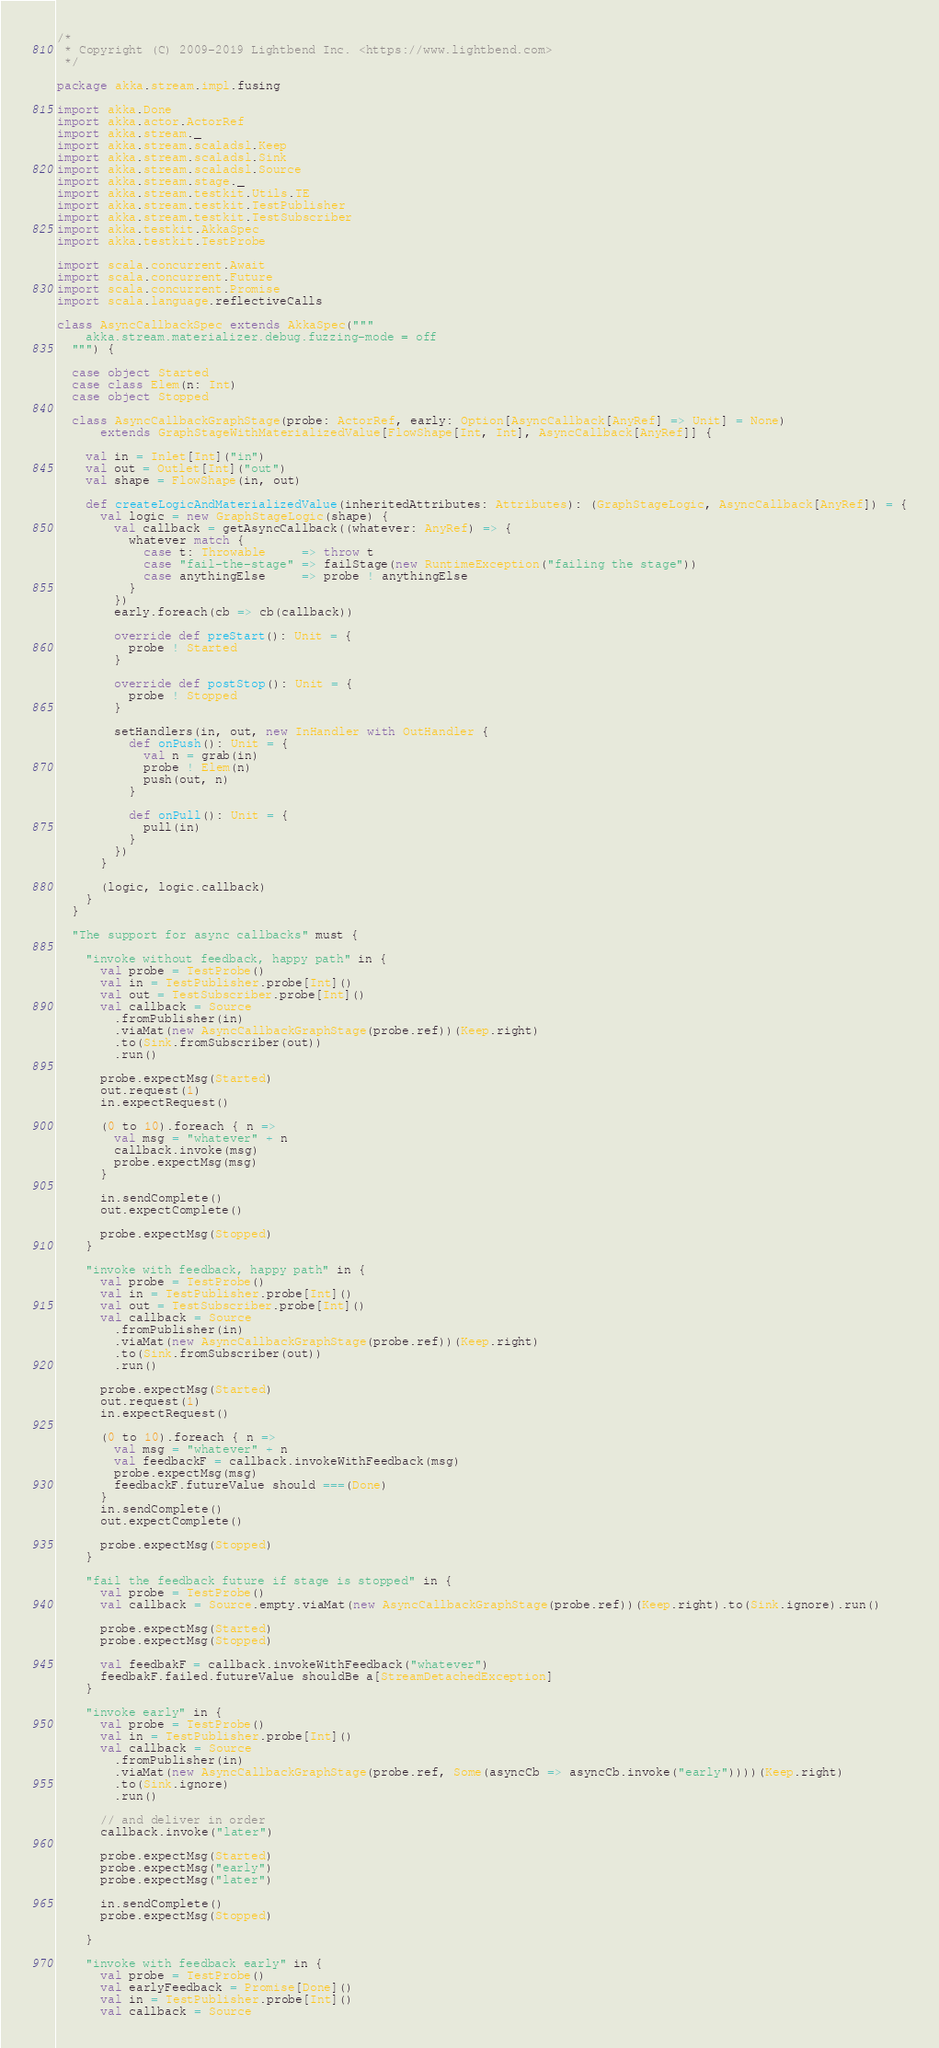Convert code to text. <code><loc_0><loc_0><loc_500><loc_500><_Scala_>/*
 * Copyright (C) 2009-2019 Lightbend Inc. <https://www.lightbend.com>
 */

package akka.stream.impl.fusing

import akka.Done
import akka.actor.ActorRef
import akka.stream._
import akka.stream.scaladsl.Keep
import akka.stream.scaladsl.Sink
import akka.stream.scaladsl.Source
import akka.stream.stage._
import akka.stream.testkit.Utils.TE
import akka.stream.testkit.TestPublisher
import akka.stream.testkit.TestSubscriber
import akka.testkit.AkkaSpec
import akka.testkit.TestProbe

import scala.concurrent.Await
import scala.concurrent.Future
import scala.concurrent.Promise
import scala.language.reflectiveCalls

class AsyncCallbackSpec extends AkkaSpec("""
    akka.stream.materializer.debug.fuzzing-mode = off
  """) {

  case object Started
  case class Elem(n: Int)
  case object Stopped

  class AsyncCallbackGraphStage(probe: ActorRef, early: Option[AsyncCallback[AnyRef] => Unit] = None)
      extends GraphStageWithMaterializedValue[FlowShape[Int, Int], AsyncCallback[AnyRef]] {

    val in = Inlet[Int]("in")
    val out = Outlet[Int]("out")
    val shape = FlowShape(in, out)

    def createLogicAndMaterializedValue(inheritedAttributes: Attributes): (GraphStageLogic, AsyncCallback[AnyRef]) = {
      val logic = new GraphStageLogic(shape) {
        val callback = getAsyncCallback((whatever: AnyRef) => {
          whatever match {
            case t: Throwable     => throw t
            case "fail-the-stage" => failStage(new RuntimeException("failing the stage"))
            case anythingElse     => probe ! anythingElse
          }
        })
        early.foreach(cb => cb(callback))

        override def preStart(): Unit = {
          probe ! Started
        }

        override def postStop(): Unit = {
          probe ! Stopped
        }

        setHandlers(in, out, new InHandler with OutHandler {
          def onPush(): Unit = {
            val n = grab(in)
            probe ! Elem(n)
            push(out, n)
          }

          def onPull(): Unit = {
            pull(in)
          }
        })
      }

      (logic, logic.callback)
    }
  }

  "The support for async callbacks" must {

    "invoke without feedback, happy path" in {
      val probe = TestProbe()
      val in = TestPublisher.probe[Int]()
      val out = TestSubscriber.probe[Int]()
      val callback = Source
        .fromPublisher(in)
        .viaMat(new AsyncCallbackGraphStage(probe.ref))(Keep.right)
        .to(Sink.fromSubscriber(out))
        .run()

      probe.expectMsg(Started)
      out.request(1)
      in.expectRequest()

      (0 to 10).foreach { n =>
        val msg = "whatever" + n
        callback.invoke(msg)
        probe.expectMsg(msg)
      }

      in.sendComplete()
      out.expectComplete()

      probe.expectMsg(Stopped)
    }

    "invoke with feedback, happy path" in {
      val probe = TestProbe()
      val in = TestPublisher.probe[Int]()
      val out = TestSubscriber.probe[Int]()
      val callback = Source
        .fromPublisher(in)
        .viaMat(new AsyncCallbackGraphStage(probe.ref))(Keep.right)
        .to(Sink.fromSubscriber(out))
        .run()

      probe.expectMsg(Started)
      out.request(1)
      in.expectRequest()

      (0 to 10).foreach { n =>
        val msg = "whatever" + n
        val feedbackF = callback.invokeWithFeedback(msg)
        probe.expectMsg(msg)
        feedbackF.futureValue should ===(Done)
      }
      in.sendComplete()
      out.expectComplete()

      probe.expectMsg(Stopped)
    }

    "fail the feedback future if stage is stopped" in {
      val probe = TestProbe()
      val callback = Source.empty.viaMat(new AsyncCallbackGraphStage(probe.ref))(Keep.right).to(Sink.ignore).run()

      probe.expectMsg(Started)
      probe.expectMsg(Stopped)

      val feedbakF = callback.invokeWithFeedback("whatever")
      feedbakF.failed.futureValue shouldBe a[StreamDetachedException]
    }

    "invoke early" in {
      val probe = TestProbe()
      val in = TestPublisher.probe[Int]()
      val callback = Source
        .fromPublisher(in)
        .viaMat(new AsyncCallbackGraphStage(probe.ref, Some(asyncCb => asyncCb.invoke("early"))))(Keep.right)
        .to(Sink.ignore)
        .run()

      // and deliver in order
      callback.invoke("later")

      probe.expectMsg(Started)
      probe.expectMsg("early")
      probe.expectMsg("later")

      in.sendComplete()
      probe.expectMsg(Stopped)

    }

    "invoke with feedback early" in {
      val probe = TestProbe()
      val earlyFeedback = Promise[Done]()
      val in = TestPublisher.probe[Int]()
      val callback = Source</code> 